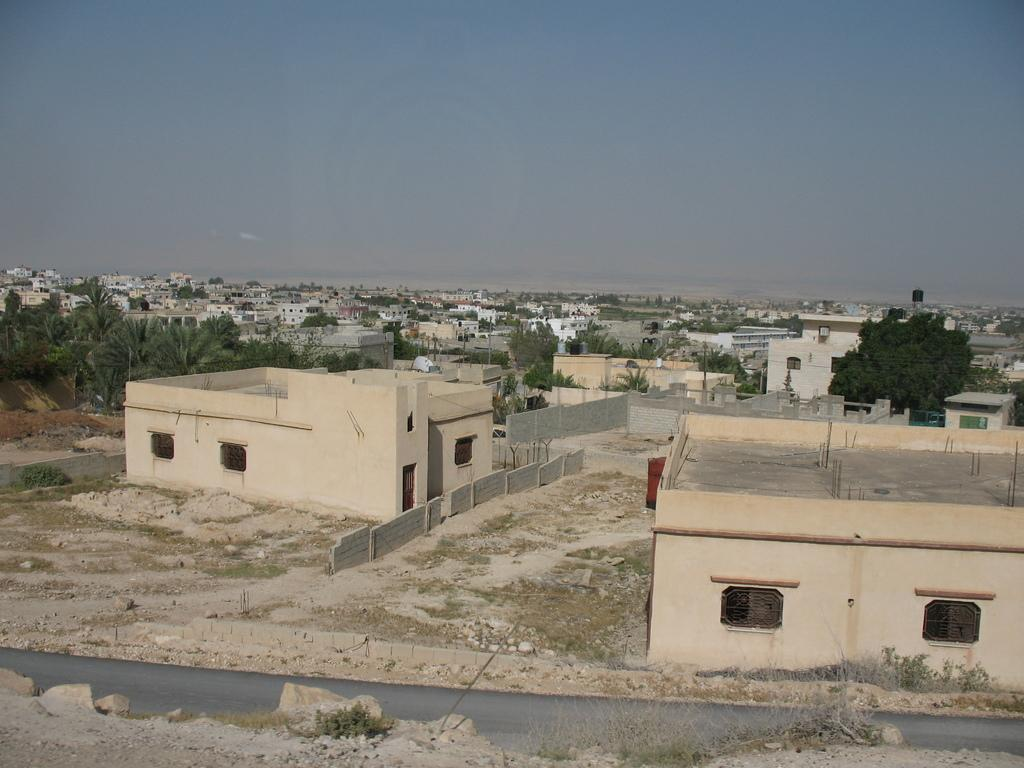What type of structures can be seen in the image? There are buildings in the image. What natural elements are present in the image? There are trees, plants, and grass in the image. What architectural feature can be seen in the image? There is a wall in the image. What is the surface on which the buildings and other elements are situated? There is ground visible in the image. What part of the natural environment is visible in the background of the image? The sky is visible in the background of the image. What type of powder is being used to wash the buildings in the image? There is no powder or washing activity depicted in the image; it features buildings, trees, plants, grass, a wall, ground, and the sky. 